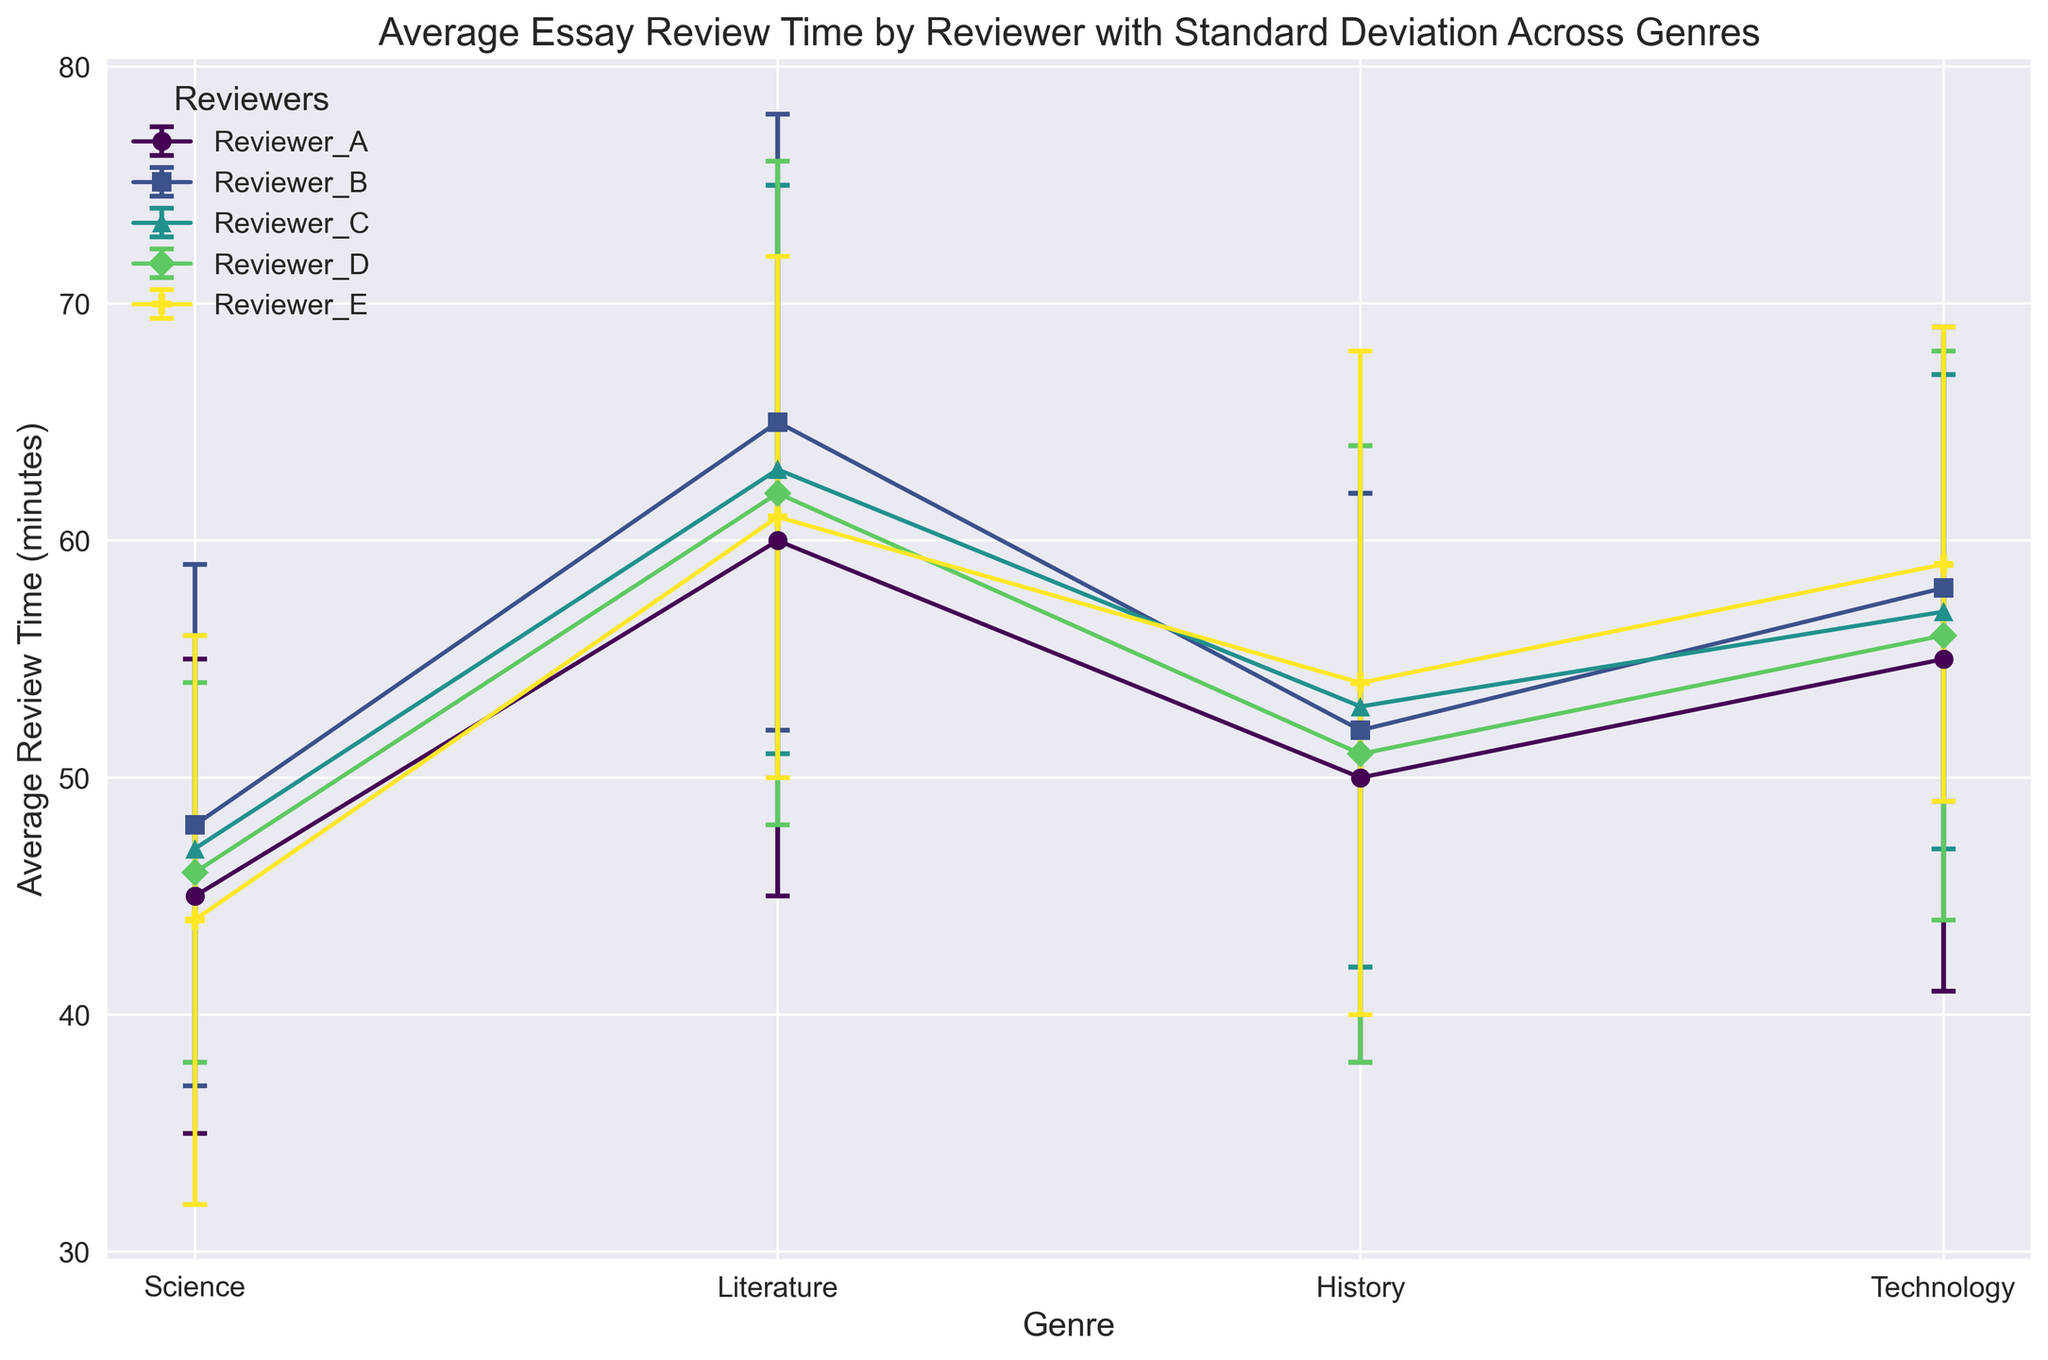What is the average review time for Reviewer_A across all genres? To find the average review time for Reviewer_A across all genres, sum the average review times for each genre and divide by the number of genres. The values are 45, 60, 50, and 55. The sum is 45 + 60 + 50 + 55 = 210. Dividing by 4 genres gives 210 / 4.
Answer: 52.5 Which reviewer has the highest average review time for Literature? To determine the reviewer with the highest average review time for Literature, look at the average review times for Literature across all reviewers: Reviewer_A (60), Reviewer_B (65), Reviewer_C (63), Reviewer_D (62), Reviewer_E (61). The highest value is 65, which belongs to Reviewer_B.
Answer: Reviewer_B What is the difference in average review times between Reviewer_C and Reviewer_E for Technology? Subtract the average review time for Reviewer_E from that for Reviewer_C in the Technology genre. Reviewer_C’s average review time is 57, and Reviewer_E’s is 59. The calculation is 57 - 59.
Answer: -2 Which genre has the smallest average review time for Reviewer_D? Examine the average review times across all genres for Reviewer_D: Science (46), Literature (62), History (51), Technology (56). The smallest average review time is for Science.
Answer: Science What is the range of the average review times for Reviewer_A? To find the range, subtract the smallest average review time (Science, 45) from the largest average review time (Literature, 60). The calculation is 60 - 45.
Answer: 15 Which reviewer has the least variability in review times for Science? Variability is indicated by the standard deviation. For Science, standard deviations are: Reviewer_A (10), Reviewer_B (11), Reviewer_C (9), Reviewer_D (8), Reviewer_E (12). The smallest standard deviation is 8, which belongs to Reviewer_D.
Answer: Reviewer_D What is the average standard deviation of review times for History across all reviewers? Sum the standard deviations for History across all reviewers and divide by the number of reviewers: Reviewer_A (12), Reviewer_B (10), Reviewer_C (11), Reviewer_D (13), Reviewer_E (14). The sum is 12 + 10 + 11 + 13 + 14 = 60. Dividing by 5 reviewers gives 60 / 5.
Answer: 12 If a new reviewer, Reviewer_F, had an average review time of 48 minutes with a standard deviation of 11 for Science, would this be above or below the average review time of the current reviewers for Science? To find out, calculate the average of the current reviewers’ average review times for Science: Reviewer_A (45), Reviewer_B (48), Reviewer_C (47), Reviewer_D (46), Reviewer_E (44). The sum is 45 + 48 + 47 + 46 + 44 = 230. Dividing by 5 reviewers gives an average of 230 / 5 = 46. Reviewer_F's average time is 48, which is greater than the current average.
Answer: Above 